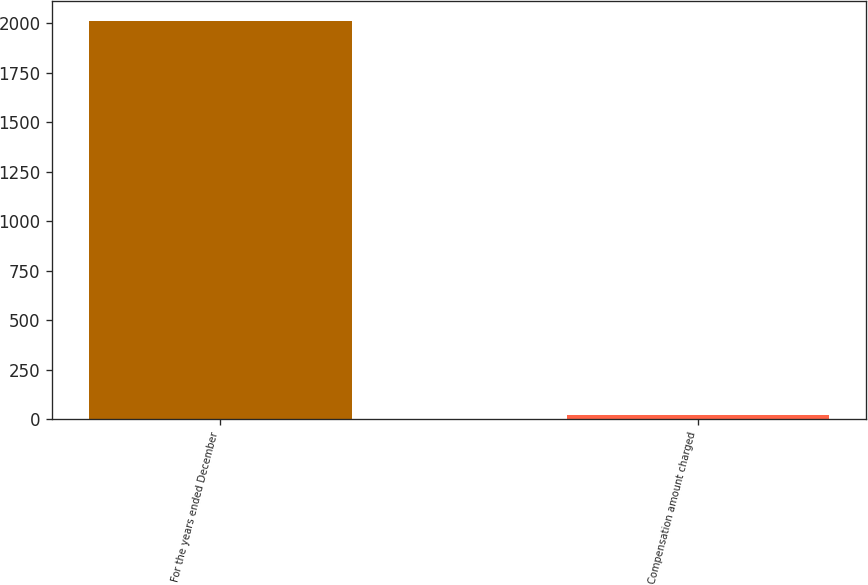<chart> <loc_0><loc_0><loc_500><loc_500><bar_chart><fcel>For the years ended December<fcel>Compensation amount charged<nl><fcel>2010<fcel>20.3<nl></chart> 